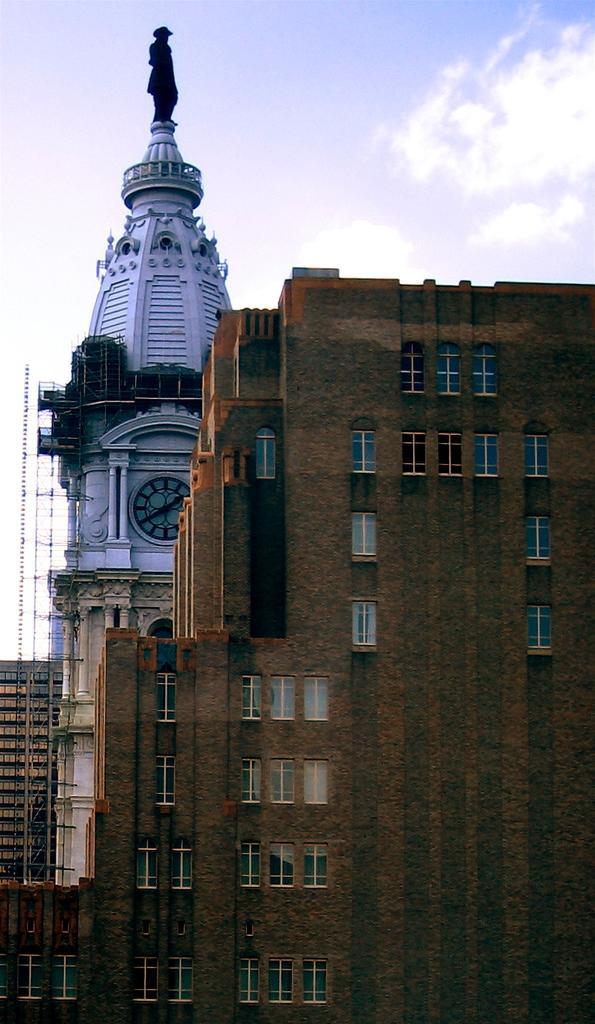How would you summarize this image in a sentence or two? In this image we can see a few buildings, on the white color building we can see a sculpture, there are some windows and grille, in the background we can see the sky with clouds. 